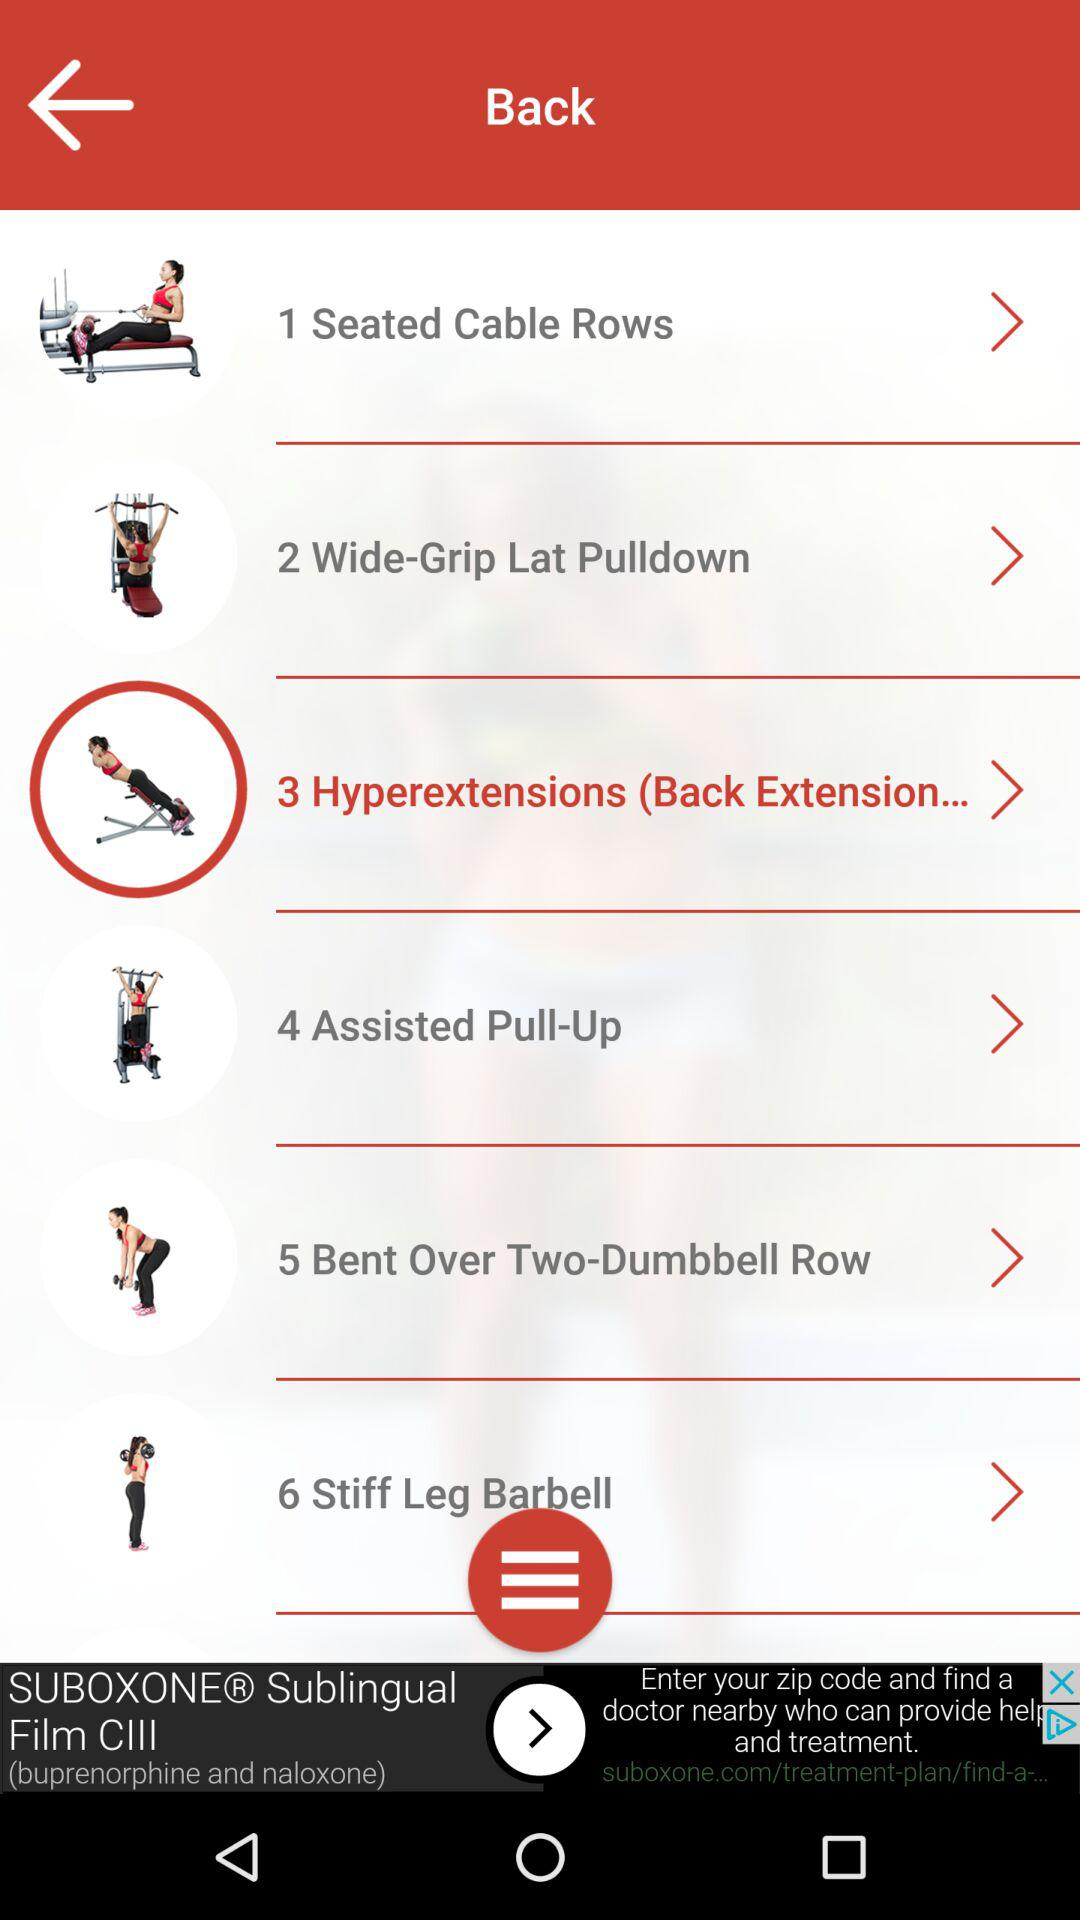What was the selected exercise? The selected exercise was "3 Hyperextensions (Back Extension... ". 